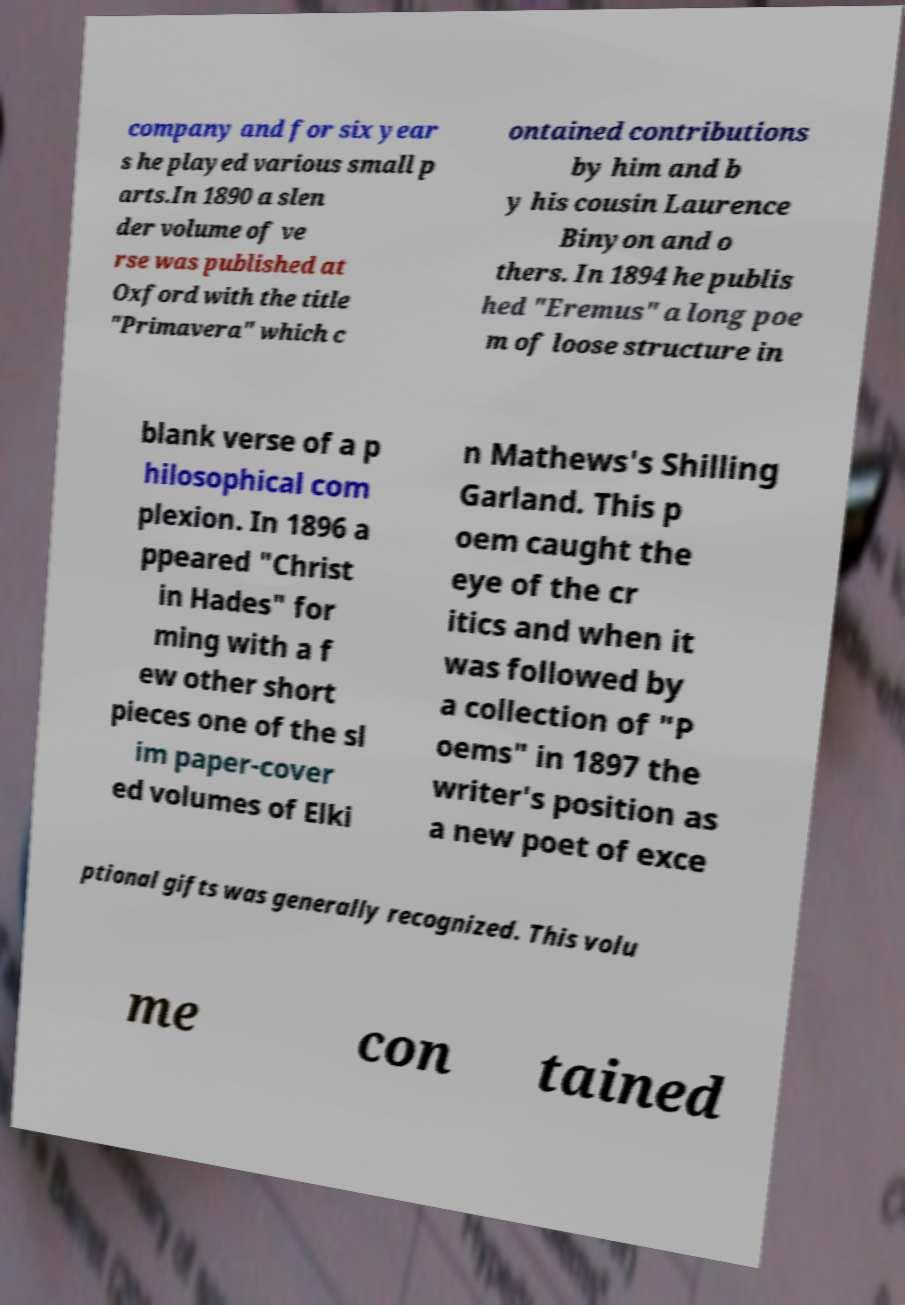What messages or text are displayed in this image? I need them in a readable, typed format. company and for six year s he played various small p arts.In 1890 a slen der volume of ve rse was published at Oxford with the title "Primavera" which c ontained contributions by him and b y his cousin Laurence Binyon and o thers. In 1894 he publis hed "Eremus" a long poe m of loose structure in blank verse of a p hilosophical com plexion. In 1896 a ppeared "Christ in Hades" for ming with a f ew other short pieces one of the sl im paper-cover ed volumes of Elki n Mathews's Shilling Garland. This p oem caught the eye of the cr itics and when it was followed by a collection of "P oems" in 1897 the writer's position as a new poet of exce ptional gifts was generally recognized. This volu me con tained 